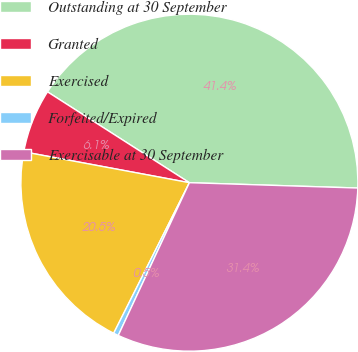Convert chart to OTSL. <chart><loc_0><loc_0><loc_500><loc_500><pie_chart><fcel>Outstanding at 30 September<fcel>Granted<fcel>Exercised<fcel>Forfeited/Expired<fcel>Exercisable at 30 September<nl><fcel>41.44%<fcel>6.13%<fcel>20.52%<fcel>0.48%<fcel>31.43%<nl></chart> 